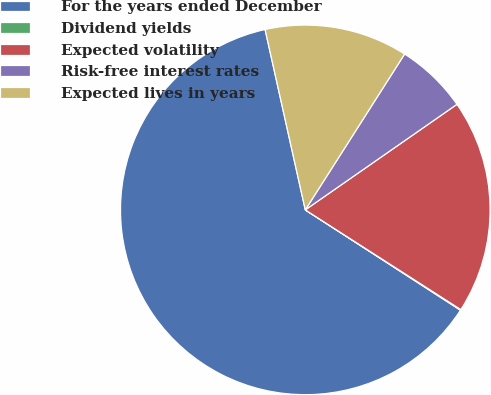<chart> <loc_0><loc_0><loc_500><loc_500><pie_chart><fcel>For the years ended December<fcel>Dividend yields<fcel>Expected volatility<fcel>Risk-free interest rates<fcel>Expected lives in years<nl><fcel>62.37%<fcel>0.06%<fcel>18.75%<fcel>6.29%<fcel>12.52%<nl></chart> 